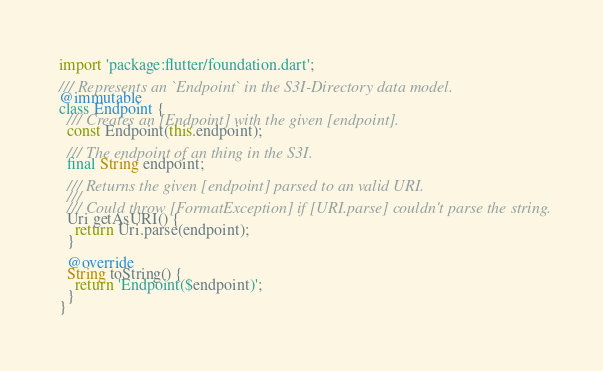<code> <loc_0><loc_0><loc_500><loc_500><_Dart_>import 'package:flutter/foundation.dart';

/// Represents an `Endpoint` in the S3I-Directory data model.
@immutable
class Endpoint {
  /// Creates an [Endpoint] with the given [endpoint].
  const Endpoint(this.endpoint);

  /// The endpoint of an thing in the S3I.
  final String endpoint;

  /// Returns the given [endpoint] parsed to an valid URI.
  ///
  /// Could throw [FormatException] if [URI.parse] couldn't parse the string.
  Uri getAsURI() {
    return Uri.parse(endpoint);
  }

  @override
  String toString() {
    return 'Endpoint($endpoint)';
  }
}
</code> 